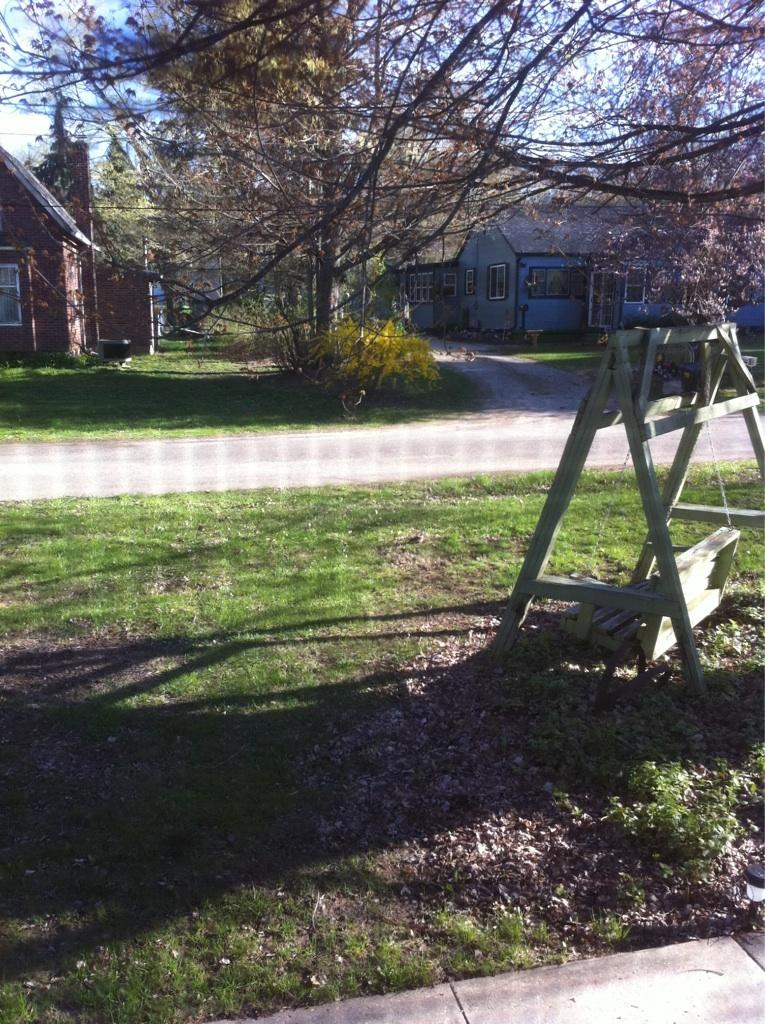What type of vegetation is present in the image? There is grass and trees in the image. What recreational object can be seen in the image? There is a swing in the image. What structure is present in the image? There is a stand in the image. What can be seen in the background of the image? In the background, there are houses, grass, plants, trees, and the sky. What type of pan is being used to cook food in the image? There is no pan or cooking activity present in the image. Is there a baby visible in the image? No, there is no baby present in the image. What is the condition of the chin of the person in the image? There is no person or chin visible in the image. 